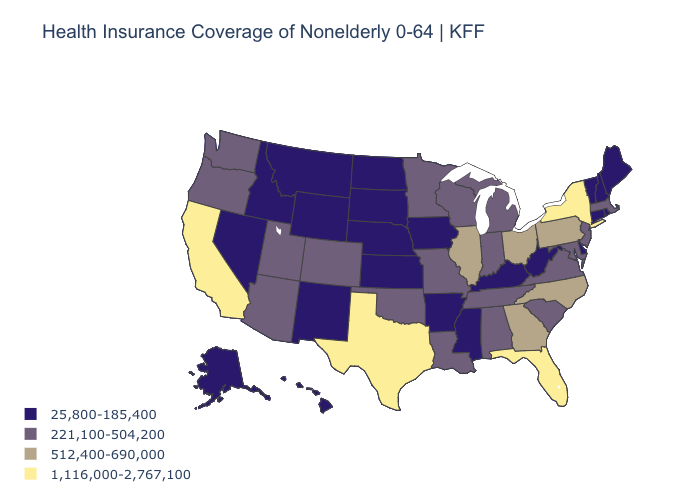Name the states that have a value in the range 1,116,000-2,767,100?
Give a very brief answer. California, Florida, New York, Texas. What is the value of Missouri?
Give a very brief answer. 221,100-504,200. Name the states that have a value in the range 512,400-690,000?
Write a very short answer. Georgia, Illinois, North Carolina, Ohio, Pennsylvania. How many symbols are there in the legend?
Give a very brief answer. 4. Does Vermont have the lowest value in the Northeast?
Concise answer only. Yes. Among the states that border New Jersey , which have the lowest value?
Write a very short answer. Delaware. Name the states that have a value in the range 25,800-185,400?
Short answer required. Alaska, Arkansas, Connecticut, Delaware, Hawaii, Idaho, Iowa, Kansas, Kentucky, Maine, Mississippi, Montana, Nebraska, Nevada, New Hampshire, New Mexico, North Dakota, Rhode Island, South Dakota, Vermont, West Virginia, Wyoming. What is the value of Arizona?
Be succinct. 221,100-504,200. What is the value of Maine?
Be succinct. 25,800-185,400. Which states have the lowest value in the West?
Concise answer only. Alaska, Hawaii, Idaho, Montana, Nevada, New Mexico, Wyoming. Among the states that border Pennsylvania , which have the lowest value?
Be succinct. Delaware, West Virginia. Among the states that border Delaware , does Pennsylvania have the lowest value?
Quick response, please. No. Among the states that border Florida , which have the lowest value?
Concise answer only. Alabama. Name the states that have a value in the range 25,800-185,400?
Quick response, please. Alaska, Arkansas, Connecticut, Delaware, Hawaii, Idaho, Iowa, Kansas, Kentucky, Maine, Mississippi, Montana, Nebraska, Nevada, New Hampshire, New Mexico, North Dakota, Rhode Island, South Dakota, Vermont, West Virginia, Wyoming. Does the first symbol in the legend represent the smallest category?
Write a very short answer. Yes. 